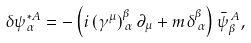Convert formula to latex. <formula><loc_0><loc_0><loc_500><loc_500>\delta \psi _ { \alpha } ^ { * A } = - \left ( i \left ( \gamma ^ { \mu } \right ) _ { \, \alpha } ^ { \beta } \partial _ { \mu } + m \delta _ { \, \alpha } ^ { \beta } \right ) \bar { \psi } _ { \beta } ^ { \, A } ,</formula> 